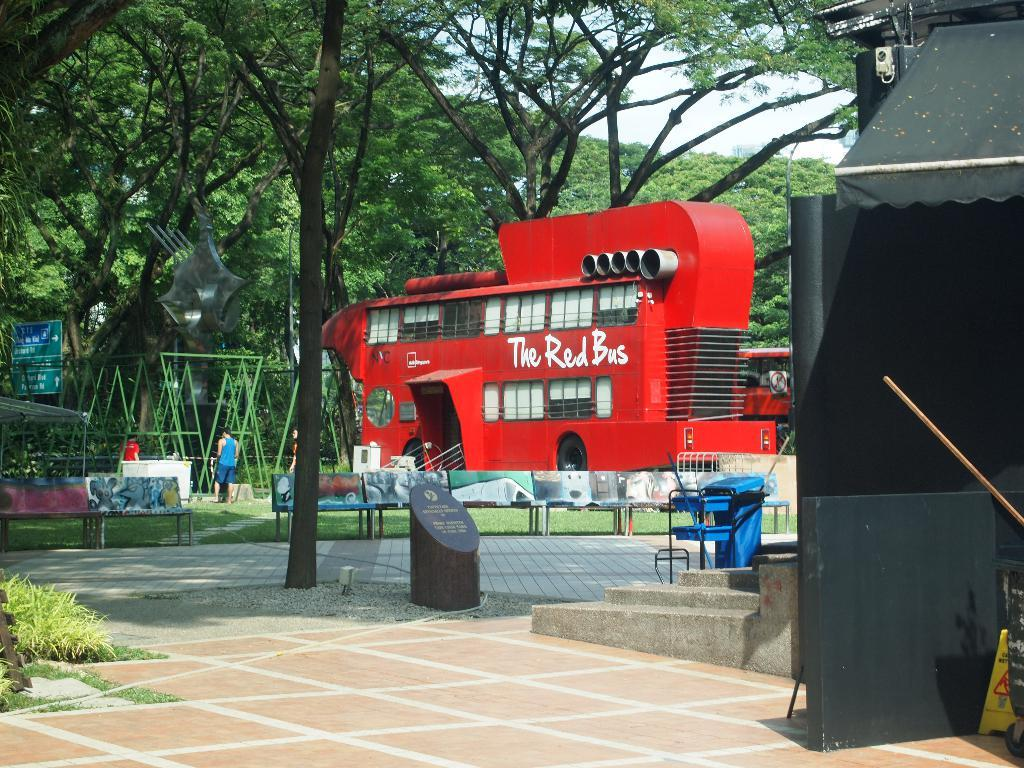What type of vehicle is in the image? There is a red bus in the image. Where is the bus located? The bus is on a greenery ground. Are there any people near the bus? Yes, there are people standing beside the bus. What can be seen in the background of the image? There are trees in the background of the image. What shape is the channel in the image? There is no channel present in the image. 